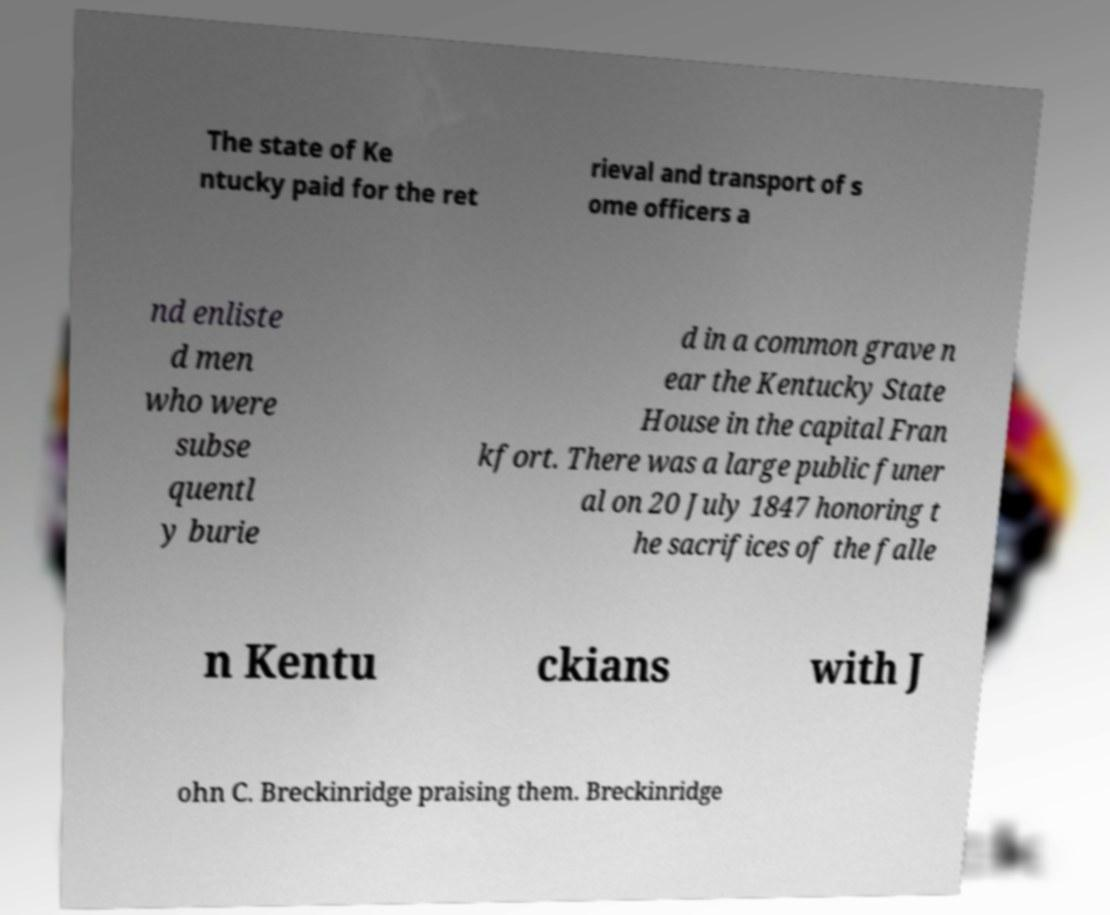There's text embedded in this image that I need extracted. Can you transcribe it verbatim? The state of Ke ntucky paid for the ret rieval and transport of s ome officers a nd enliste d men who were subse quentl y burie d in a common grave n ear the Kentucky State House in the capital Fran kfort. There was a large public funer al on 20 July 1847 honoring t he sacrifices of the falle n Kentu ckians with J ohn C. Breckinridge praising them. Breckinridge 